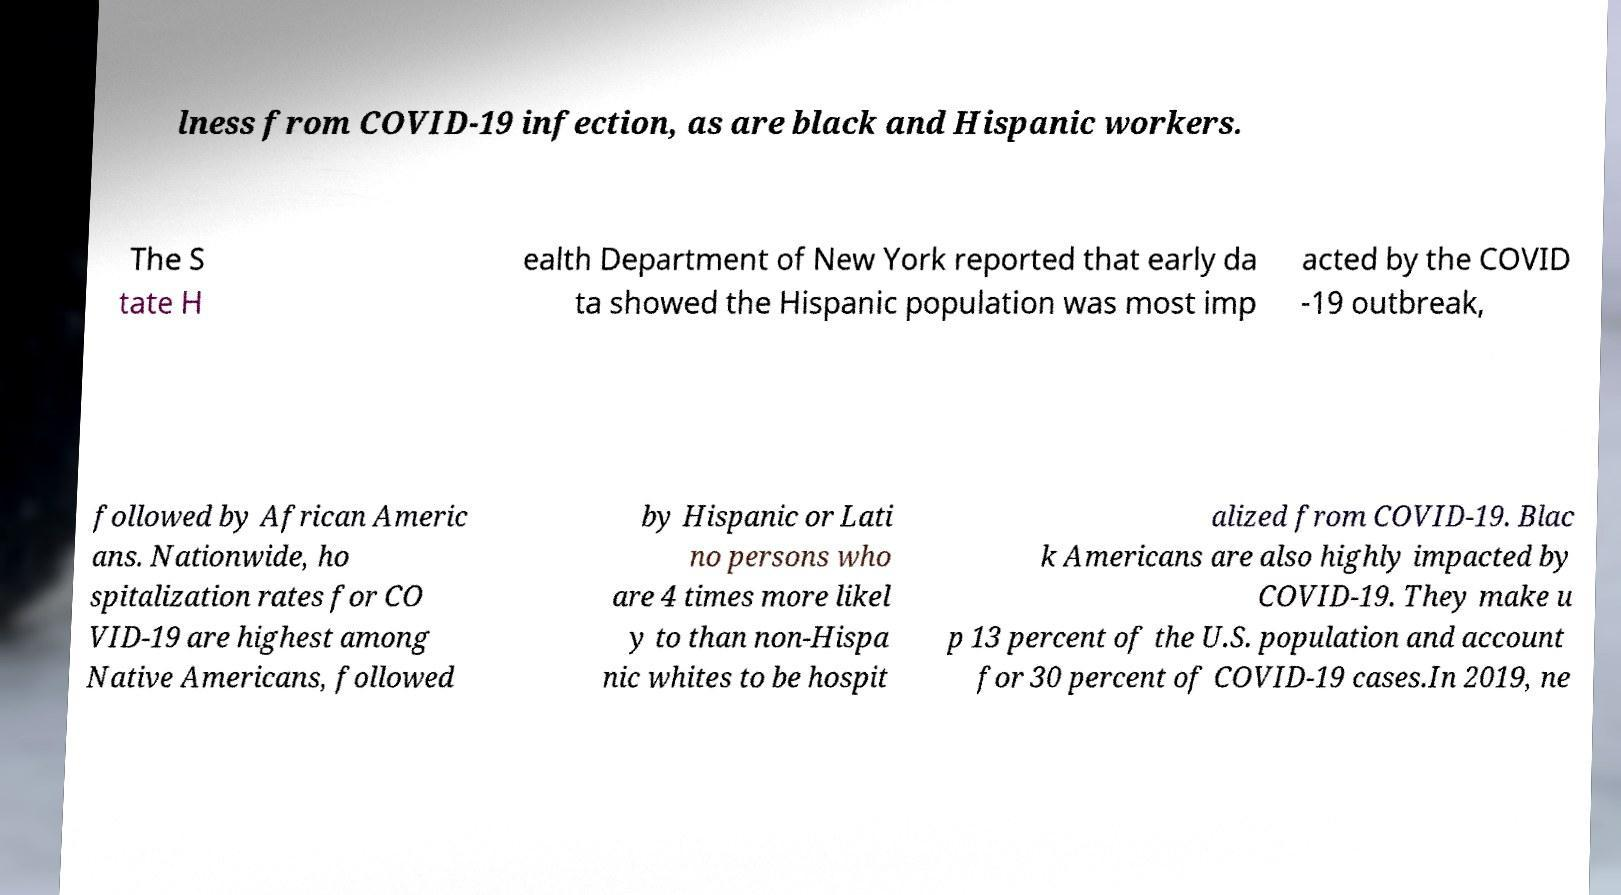I need the written content from this picture converted into text. Can you do that? lness from COVID-19 infection, as are black and Hispanic workers. The S tate H ealth Department of New York reported that early da ta showed the Hispanic population was most imp acted by the COVID -19 outbreak, followed by African Americ ans. Nationwide, ho spitalization rates for CO VID-19 are highest among Native Americans, followed by Hispanic or Lati no persons who are 4 times more likel y to than non-Hispa nic whites to be hospit alized from COVID-19. Blac k Americans are also highly impacted by COVID-19. They make u p 13 percent of the U.S. population and account for 30 percent of COVID-19 cases.In 2019, ne 